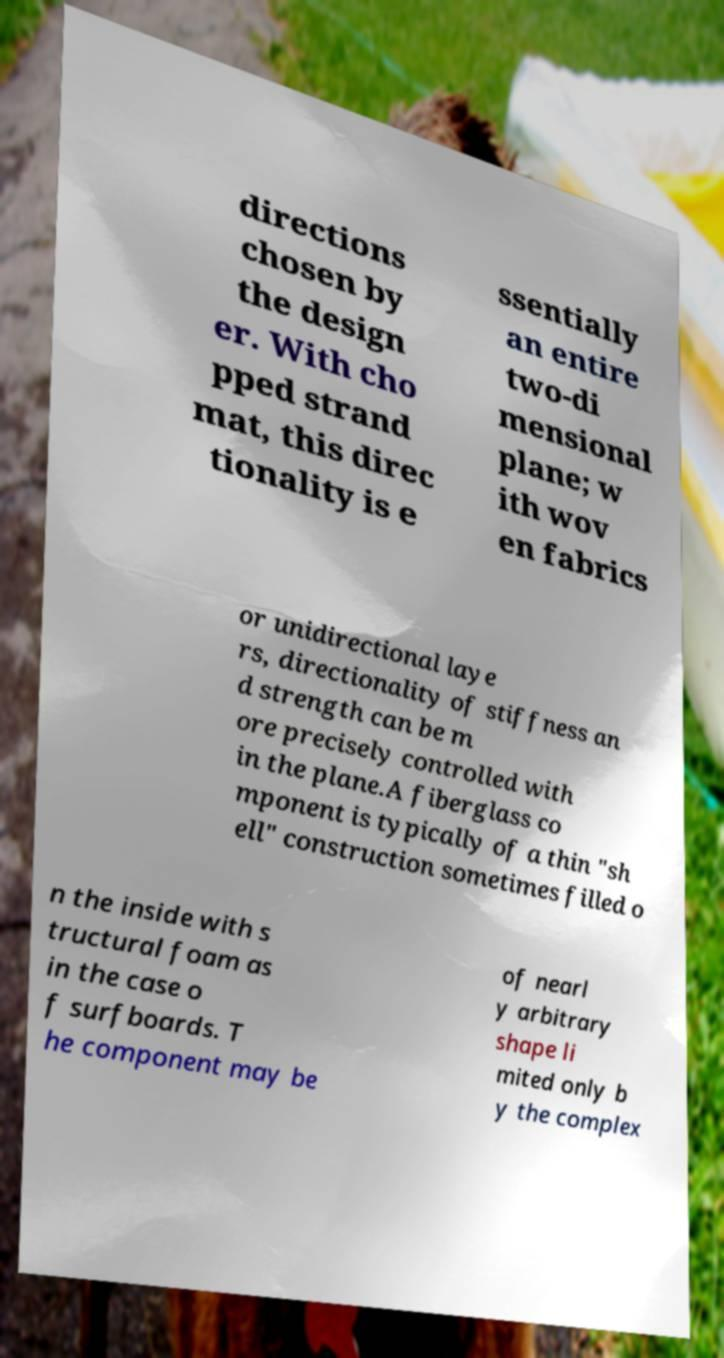Can you accurately transcribe the text from the provided image for me? directions chosen by the design er. With cho pped strand mat, this direc tionality is e ssentially an entire two-di mensional plane; w ith wov en fabrics or unidirectional laye rs, directionality of stiffness an d strength can be m ore precisely controlled with in the plane.A fiberglass co mponent is typically of a thin "sh ell" construction sometimes filled o n the inside with s tructural foam as in the case o f surfboards. T he component may be of nearl y arbitrary shape li mited only b y the complex 